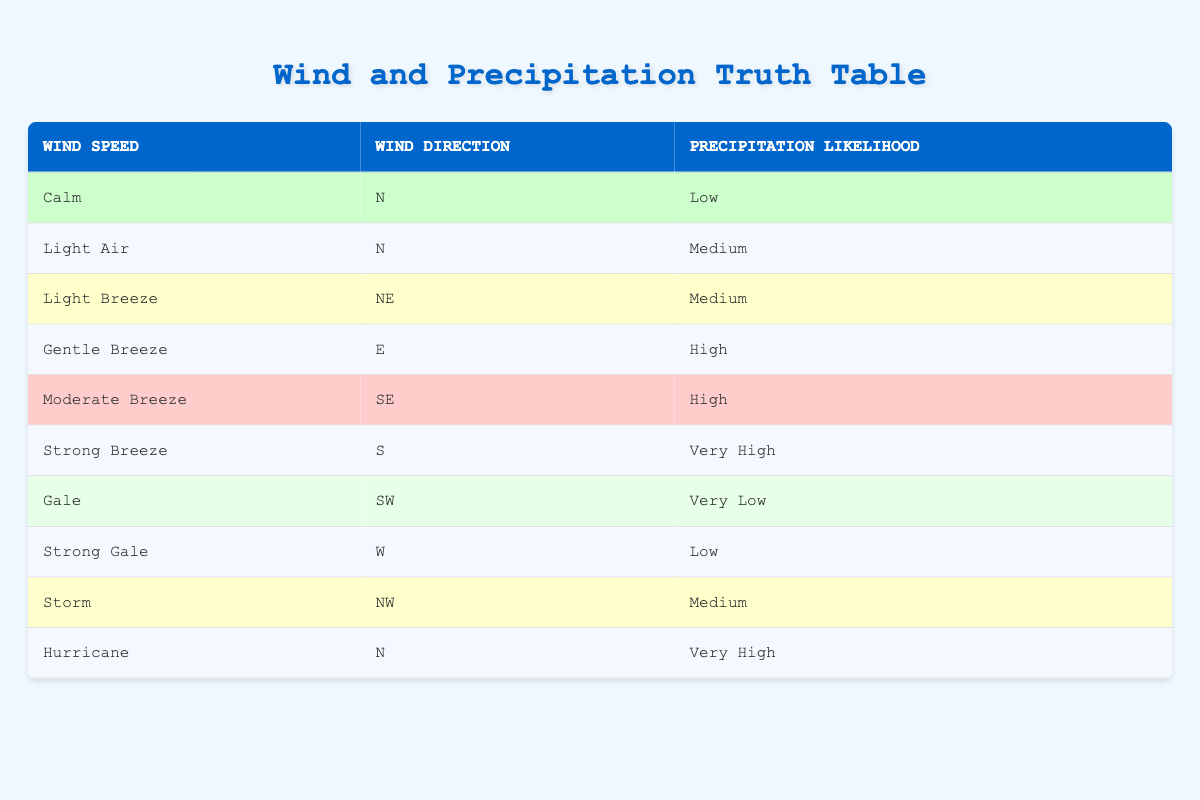What is the precipitation likelihood when the wind speed is classified as a Strong Breeze? In the table, we look for the row that specifies the wind speed as Strong Breeze. According to the data, the precipitation likelihood for Strong Breeze is Very High.
Answer: Very High Which wind direction corresponds to the highest precipitation likelihood? To find the highest precipitation likelihood, we identify the likelihoods in the table. The highest likelihood is Very High, which occurs for both Strong Breeze (S) and Hurricane (N). The corresponding wind directions are S and N.
Answer: S and N Are there any wind speeds that have a Low precipitation likelihood? We examine the table for all entries with a Low precipitation likelihood. Both Calm (N) and Strong Gale (W) have a Low likelihood. Therefore, the answer is yes, there are entries with Low likelihood.
Answer: Yes What is the average precipitation likelihood across all wind speeds? The likelihoods are categorized as Very Low, Low, Medium, High, and Very High. In terms of numerical representation: Very Low (1), Low (2), Medium (3), High (4), Very High (5). There are 10 entries, their assigned values are (1 + 2 + 2 + 3 + 3 + 4 + 1 + 2 + 3 + 5) = 26. The average is 26/10 = 2.6, which translates back to a bit above Medium.
Answer: Above Medium Which wind speed has the same precipitation likelihood as the Gentle Breeze? A close inspection of the table shows that Gentle Breeze has a High precipitation likelihood. We then need to look for any other wind speeds that match this level. Moderate Breeze (SE) also has High likelihood.
Answer: Gentle Breeze and Moderate Breeze What is the likelihood of precipitation when the wind is Calm and from the North? We check the table for the conditions specified: Calm and N. Looking at the corresponding row, we see that the precipitation likelihood for these conditions is Low.
Answer: Low What are the wind directions associated with Medium precipitation likelihood? To answer this, we collect all instances in the table where the precipitation likelihood is Medium. This occurs under Light Air (N), Light Breeze (NE), and Storm (NW). Therefore, the wind directions that meet this criteria are N, NE, and NW.
Answer: N, NE, NW Does the Hurricane produce any precipitation likelihood lower than Medium? We review the table for Hurricane. The precipitation likelihood is Very High, which confirms it does not produce lower than Medium likelihood. Thus, the answer to the question is no.
Answer: No 